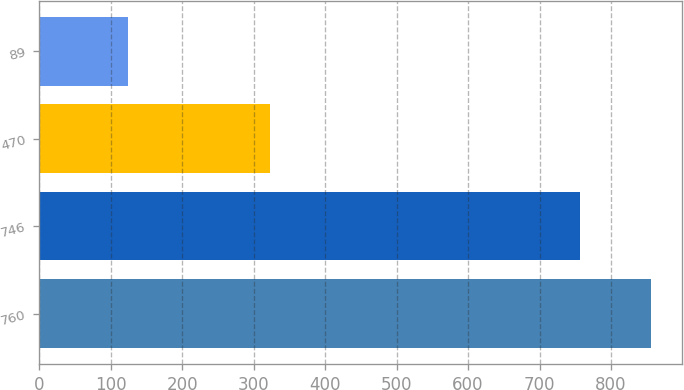Convert chart. <chart><loc_0><loc_0><loc_500><loc_500><bar_chart><fcel>760<fcel>746<fcel>470<fcel>89<nl><fcel>856<fcel>757<fcel>323<fcel>124<nl></chart> 